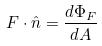Convert formula to latex. <formula><loc_0><loc_0><loc_500><loc_500>F \cdot \hat { n } = \frac { d \Phi _ { F } } { d A }</formula> 